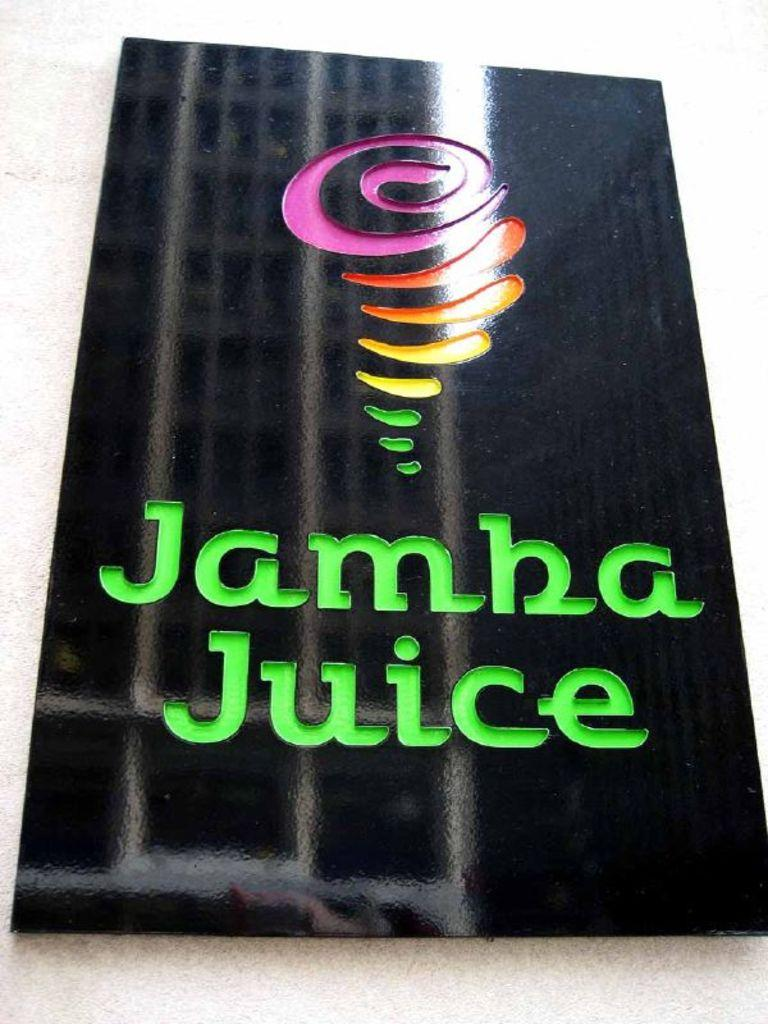<image>
Offer a succinct explanation of the picture presented. A sign for Jamba Juice hanging on the wall. 